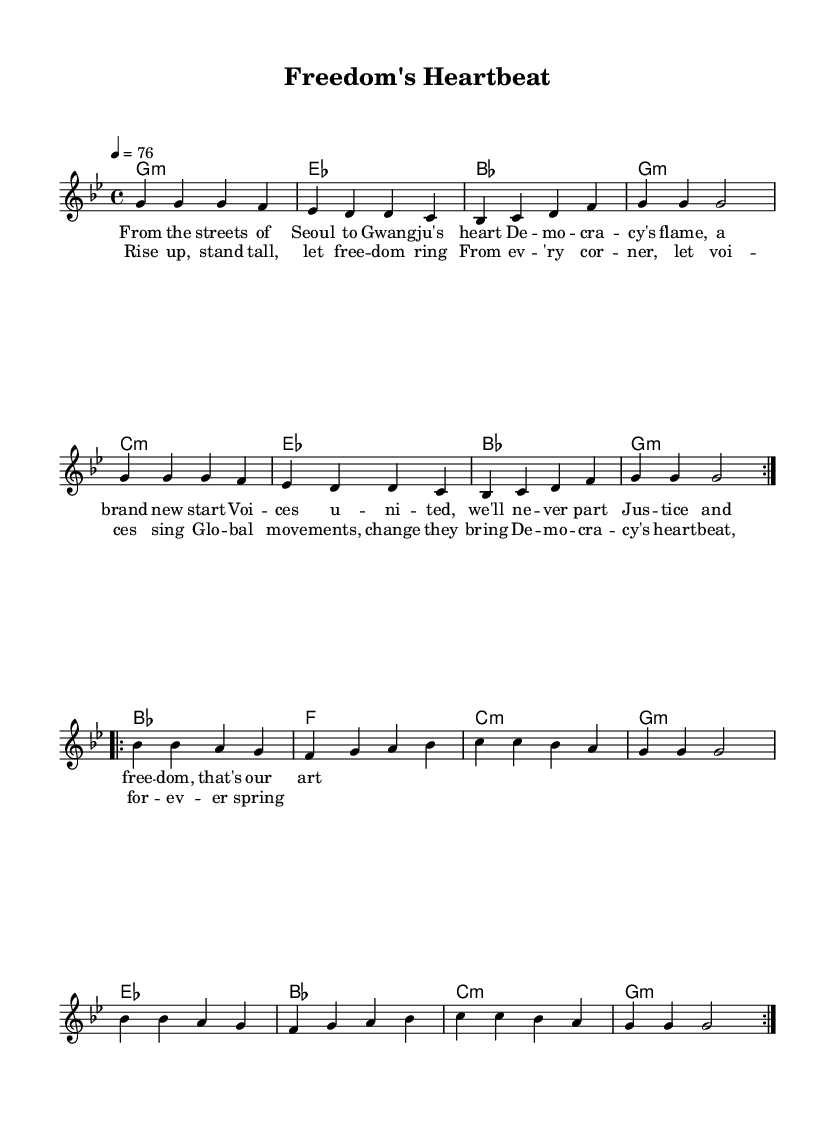What is the key signature of this music? The key signature is G minor, which has two flats (B♭ and E♭). This is indicated at the beginning of the score.
Answer: G minor What is the time signature of this music? The time signature is 4/4, which means there are four beats in each measure and the quarter note gets one beat. This is specified at the beginning of the score.
Answer: 4/4 What is the tempo marking? The tempo marking indicates a speed of 76 beats per minute for the quarter note which suggests a moderate pace. This is noted in the tempo indication at the start of the score.
Answer: 76 How many volta sections are there in the melody? There are two volta sections, as seen by the repeat marking "volta" which appears twice in the melody section. Each volta signifies a repeated segment of music.
Answer: 2 What is the first lyric line of the chorus? The first lyric line of the chorus begins with "Rise up, stand tall, let freedom ring," which reflects the theme of global movements and social justice. This is indicated under the lyrical notation in the score.
Answer: Rise up, stand tall, let freedom ring Which chord is played at the beginning of the music? The music begins with a G minor chord, indicated by the chord names in the score accompanying the melody at the start.
Answer: G minor What theme does this piece convey through its lyrics and music? The piece conveys themes of democracy and social justice, highlighted in the lyrics and the overall arrangement of the reggae genre that embodies such movements. This is interpreted through the lyrical content and their relevance to global democratic struggles.
Answer: Democracy and social justice 